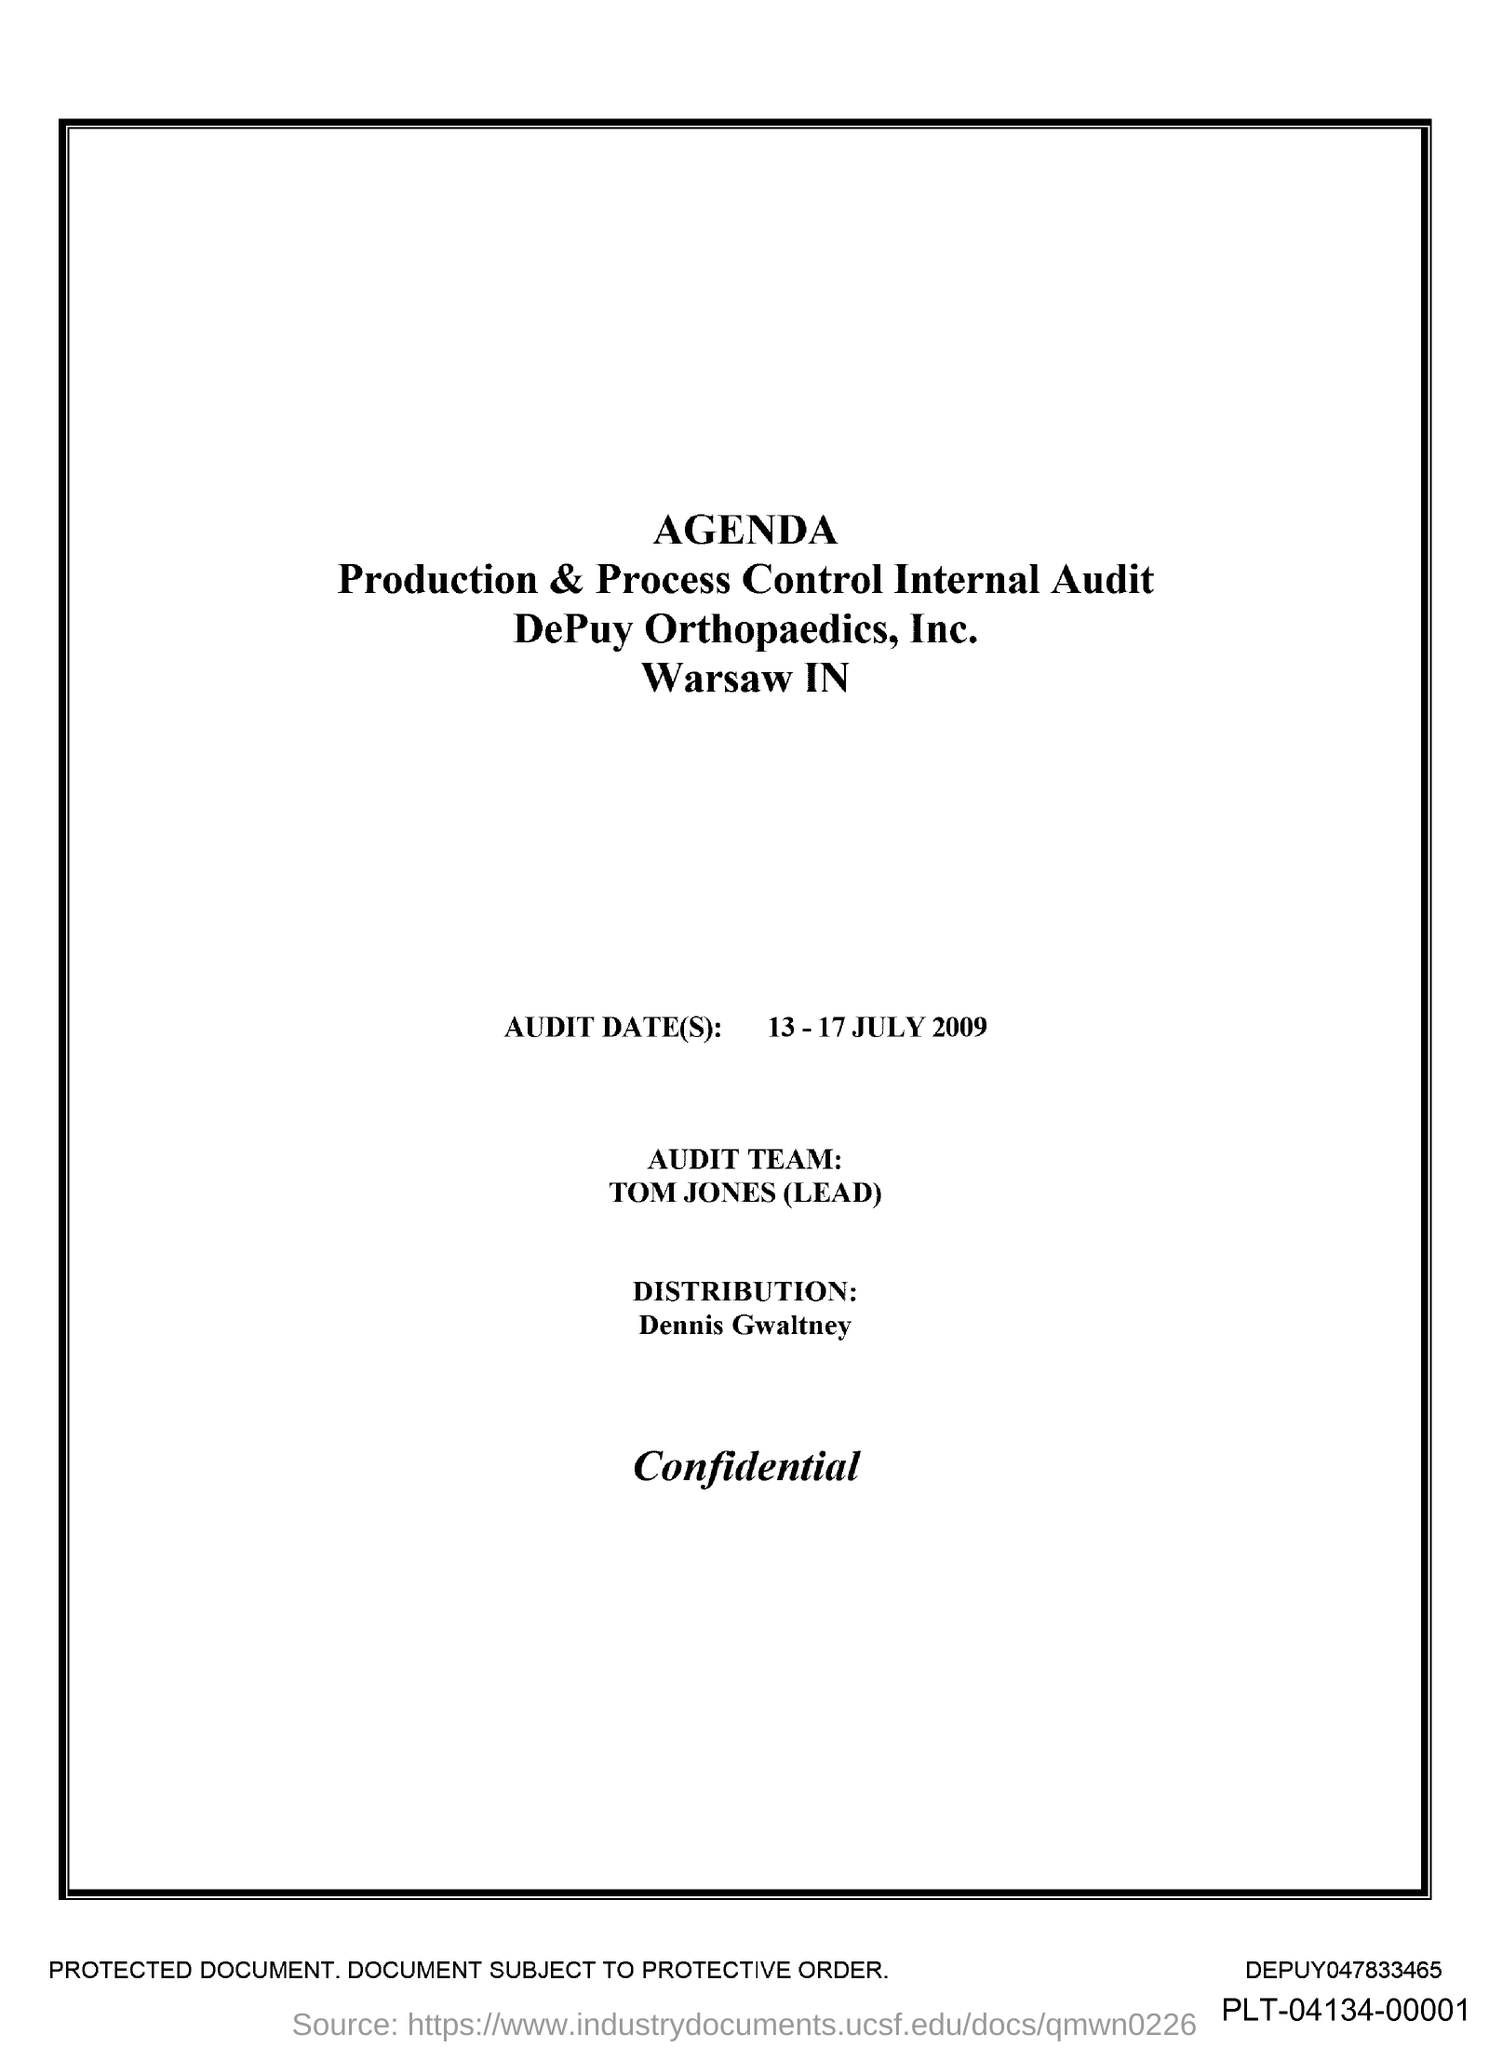What are the audit dates mentioned?
Provide a succinct answer. 13-17 JULY 2009. Who lead the audit team?
Give a very brief answer. Tom Jones. 